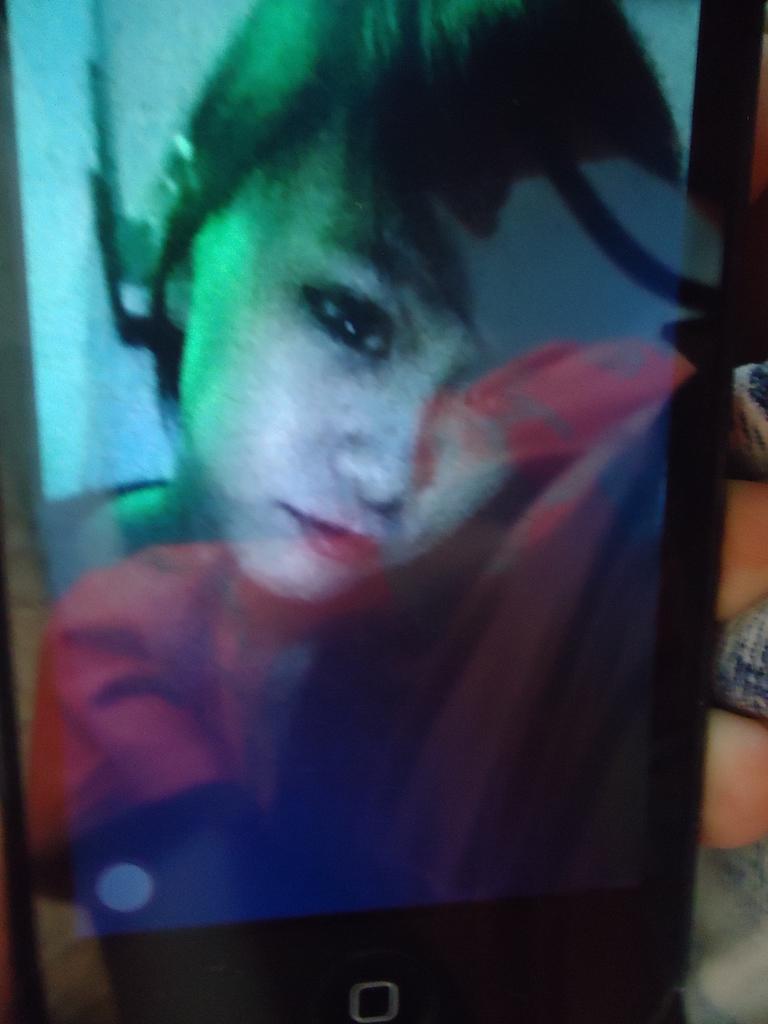Describe this image in one or two sentences. In this image we can see the picture of a person in the cell phone. 